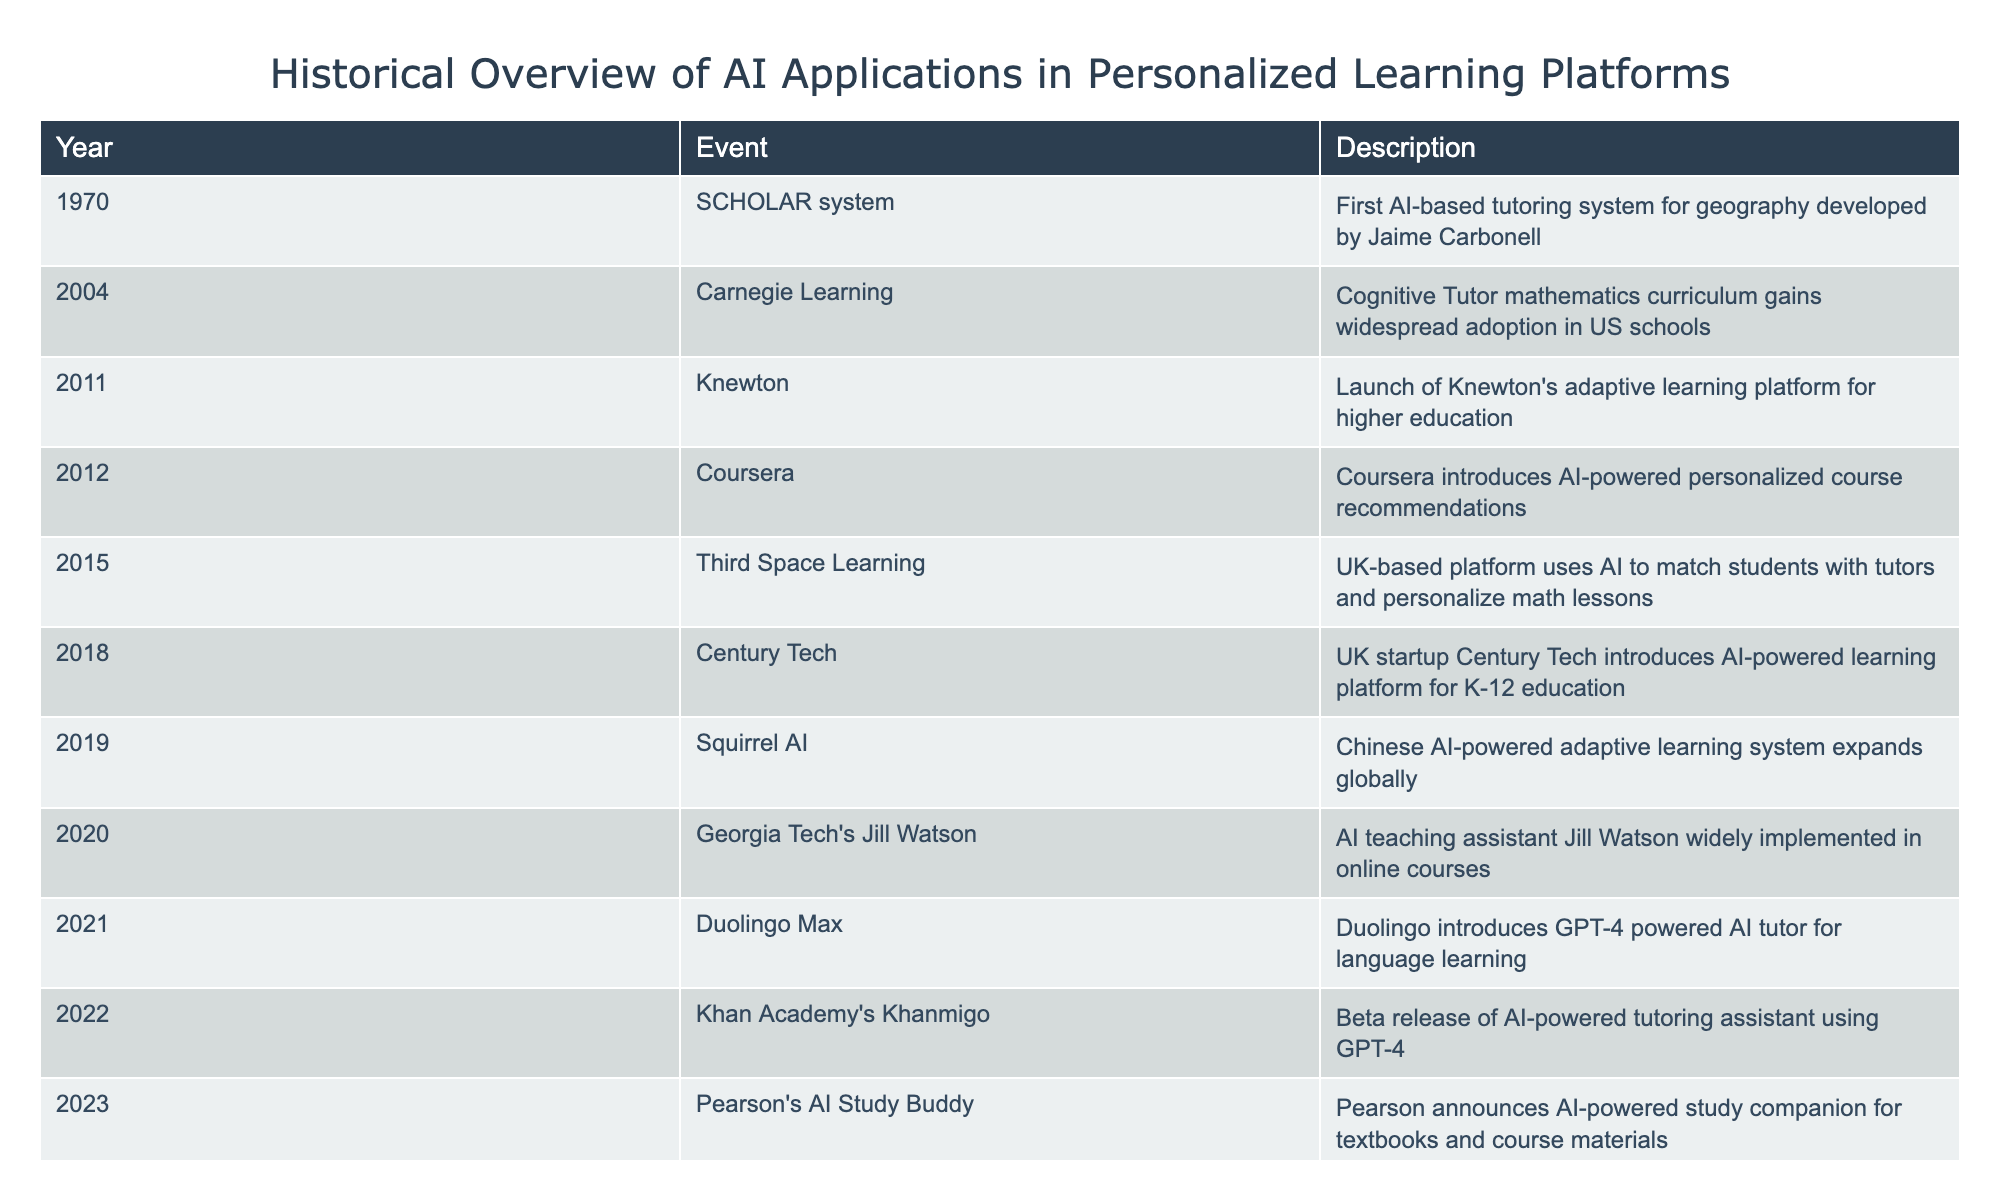What year was the SCHOLAR system developed? The SCHOLAR system was the first AI-based tutoring system for geography, which is mentioned in the row corresponding to the year 1970.
Answer: 1970 How many AI applications were introduced in the 2010s? The AI applications were introduced in the years 2011, 2012, 2015, 2018, and 2019. Counting these years gives us five applications.
Answer: 5 Was Knewton launched before Carnegie Learning's Cognitive Tutor? Knewton was launched in 2011, while Carnegie Learning's Cognitive Tutor gained widespread adoption in 2004. Since 2011 is after 2004, the answer is no.
Answer: No In which year did Pearson announce its AI-powered study companion? The announcement by Pearson regarding the AI-powered study companion occurred in 2023 as stated in the last row of the table.
Answer: 2023 What was the first AI application in personalized learning platforms according to the table? The first AI application listed in the table is the SCHOLAR system developed in 1970, which is the earliest event in the timeline.
Answer: SCHOLAR system How many years passed between the introduction of the Knewton platform and the AI Study Buddy by Pearson? Knewton was launched in 2011, and Pearson announced its AI Study Buddy in 2023. The difference in years is 2023 - 2011 = 12 years.
Answer: 12 years Which platform introduced personalized course recommendations using AI in 2012? The table indicates that Coursera introduced AI-powered personalized course recommendations in the year 2012, as stated in its description.
Answer: Coursera Is Century Tech the only AI startup mentioned in the timeline? Century Tech is mentioned as a UK startup that introduced an AI-powered learning platform; however, Squirrel AI is also referenced as a Chinese AI-powered adaptive learning system. Therefore, the statement is false.
Answer: No Which two events related to AI applications occurred in 2021? The table indicates that in 2021, Duolingo introduced an AI tutor powered by GPT-4, and it does not mention any other event for that year. Thus, there is only one event listed for 2021.
Answer: One event 